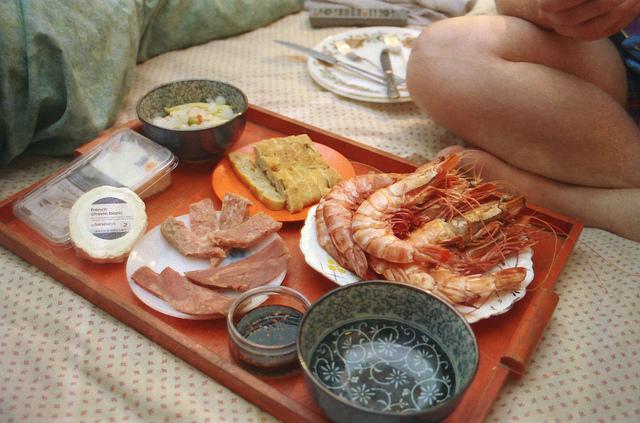How is this person seated?
Concise answer only. Yes. Would all of this food be eaten by a vegan?
Answer briefly. No. Is the diner seated at a table?
Short answer required. No. 